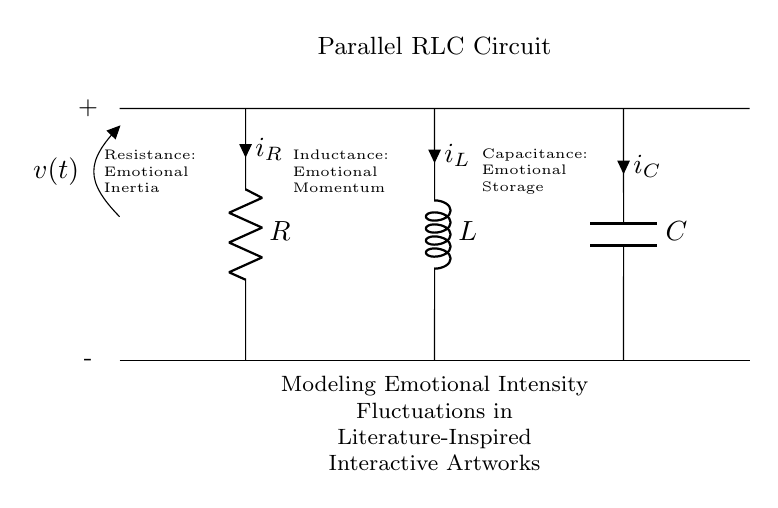What components are in the circuit? The circuit contains a resistor, inductor, and capacitor, which are the three necessary components of a parallel RLC circuit.
Answer: resistor, inductor, capacitor What does the resistor symbolize in this artistic representation? In the context of the circuit, the resistor is labeled as "Emotional Inertia," representing the resistance to change in emotional responses, akin to how resistors limit current flow in a circuit.
Answer: Emotional Inertia What is the function of the inductor in this circuit? The inductor is associated with "Emotional Momentum," which signifies how past emotions can influence current emotional states and actions.
Answer: Emotional Momentum What does the capacitor represent in this artwork model? The capacitor is identified as "Emotional Storage," capturing and holding emotional energy much like how capacitors store electrical energy in a circuit.
Answer: Emotional Storage How does emotional intensity fluctuate in this model? In this parallel RLC circuit model, emotional intensity fluctuations can be visualized as oscillations generated by the interplay of the resistor (inertia), inductor (momentum), and capacitor (storage), leading to complex emotional dynamics over time.
Answer: Oscillations What is the significance of voltage in this context? The voltage represents the emotional stimulus or input into the interactive artwork, affecting the flow of emotional energy through the circuit that corresponds to audience engagement.
Answer: Emotional Stimulus 